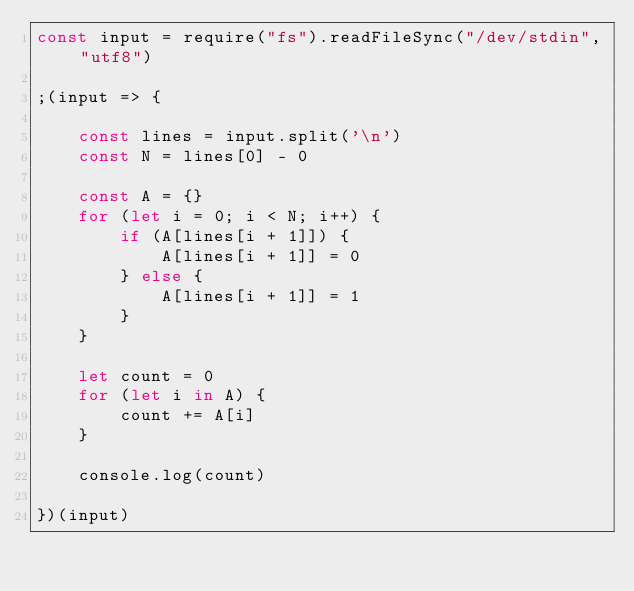<code> <loc_0><loc_0><loc_500><loc_500><_JavaScript_>const input = require("fs").readFileSync("/dev/stdin", "utf8")

;(input => {

    const lines = input.split('\n')
    const N = lines[0] - 0

    const A = {}
    for (let i = 0; i < N; i++) {
        if (A[lines[i + 1]]) {
            A[lines[i + 1]] = 0
        } else {
            A[lines[i + 1]] = 1
        }
    }

    let count = 0
    for (let i in A) {
        count += A[i]
    }

    console.log(count)

})(input)
</code> 